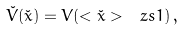Convert formula to latex. <formula><loc_0><loc_0><loc_500><loc_500>\check { V } ( \check { x } ) = V ( < \check { x } > _ { \ } z s { 1 } ) \, ,</formula> 